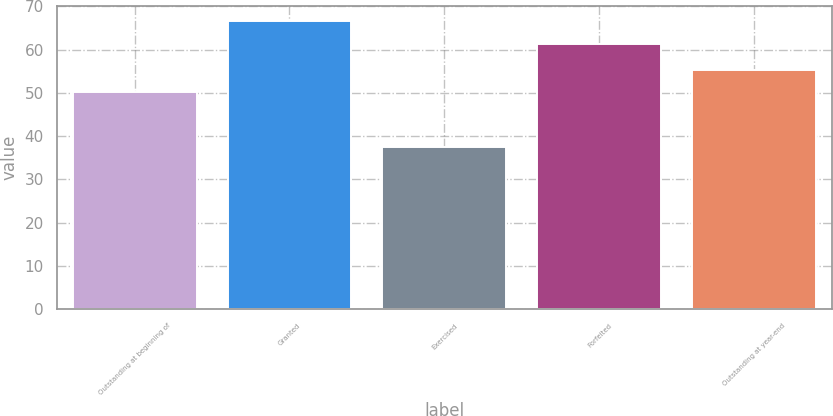Convert chart. <chart><loc_0><loc_0><loc_500><loc_500><bar_chart><fcel>Outstanding at beginning of<fcel>Granted<fcel>Exercised<fcel>Forfeited<fcel>Outstanding at year-end<nl><fcel>50.3<fcel>66.67<fcel>37.6<fcel>61.28<fcel>55.33<nl></chart> 